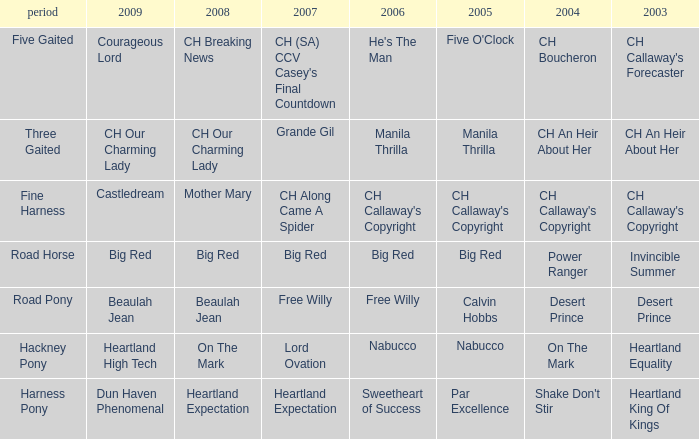What is the year for the 2004 version of "shake don't stir"? Harness Pony. 